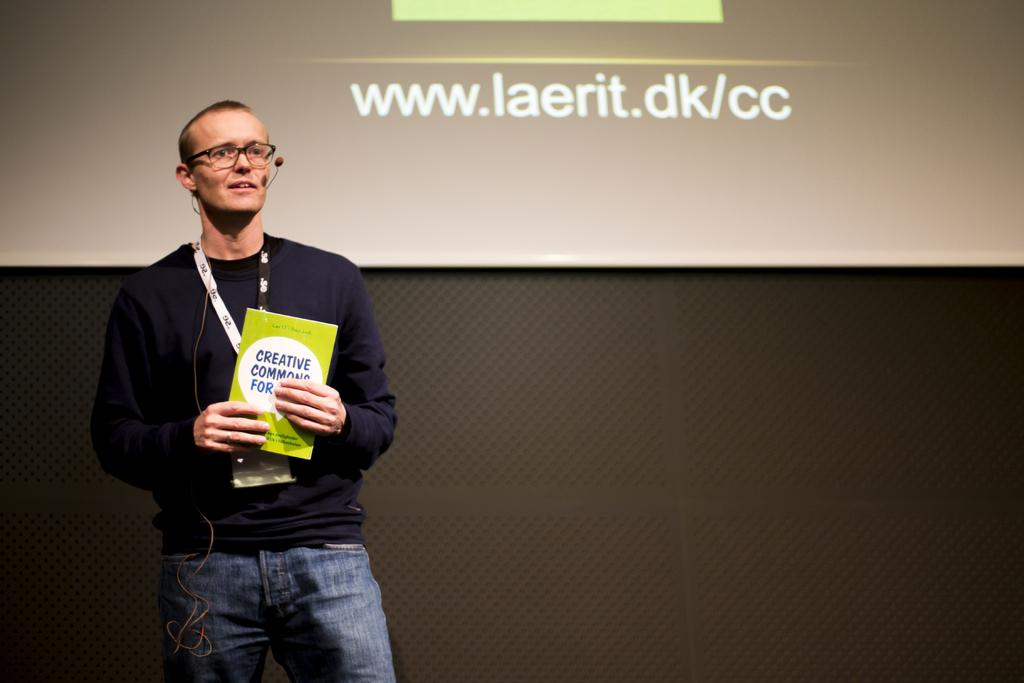What is the man in the image doing? The man is standing in the image and holding a book. What else is the man holding in the image? The man is also holding a microphone. Can you describe any identifying features of the man in the image? Yes, the man is wearing a tag. What is visible behind the man in the image? There is a screen visible behind the man, and a wall behind the screen. What type of cup is the man holding in the image? There is no cup present in the image; the man is holding a book and a microphone. 